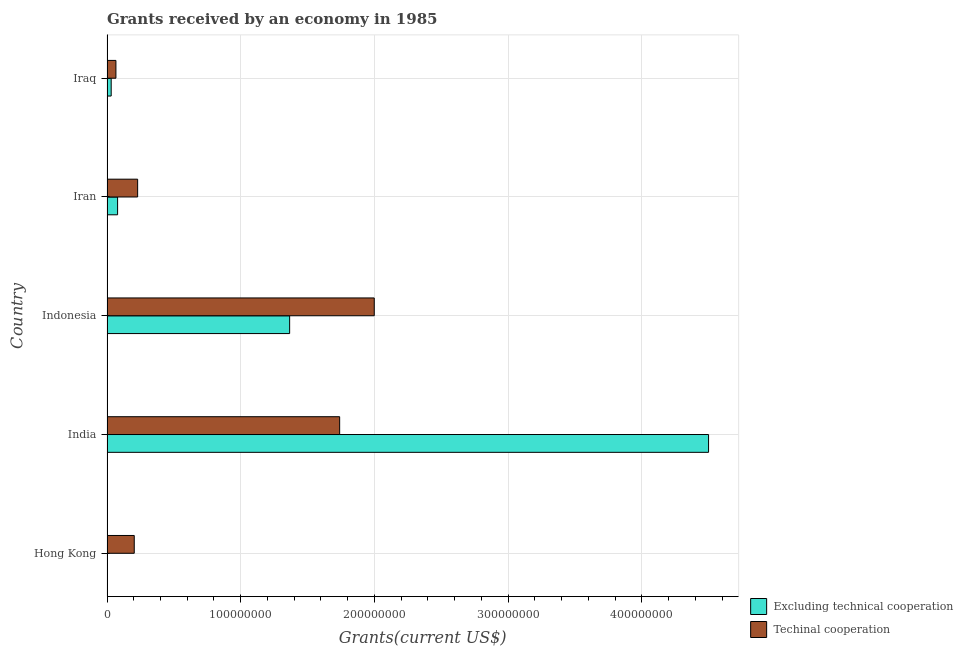Are the number of bars per tick equal to the number of legend labels?
Give a very brief answer. Yes. Are the number of bars on each tick of the Y-axis equal?
Offer a terse response. Yes. How many bars are there on the 2nd tick from the bottom?
Make the answer very short. 2. What is the label of the 2nd group of bars from the top?
Your answer should be compact. Iran. In how many cases, is the number of bars for a given country not equal to the number of legend labels?
Provide a succinct answer. 0. What is the amount of grants received(including technical cooperation) in India?
Keep it short and to the point. 1.74e+08. Across all countries, what is the maximum amount of grants received(excluding technical cooperation)?
Keep it short and to the point. 4.50e+08. Across all countries, what is the minimum amount of grants received(including technical cooperation)?
Ensure brevity in your answer.  6.67e+06. In which country was the amount of grants received(excluding technical cooperation) minimum?
Keep it short and to the point. Hong Kong. What is the total amount of grants received(excluding technical cooperation) in the graph?
Make the answer very short. 5.97e+08. What is the difference between the amount of grants received(excluding technical cooperation) in India and that in Indonesia?
Make the answer very short. 3.13e+08. What is the difference between the amount of grants received(excluding technical cooperation) in Iran and the amount of grants received(including technical cooperation) in India?
Your answer should be compact. -1.66e+08. What is the average amount of grants received(including technical cooperation) per country?
Provide a short and direct response. 8.48e+07. What is the difference between the amount of grants received(including technical cooperation) and amount of grants received(excluding technical cooperation) in Hong Kong?
Offer a terse response. 2.04e+07. In how many countries, is the amount of grants received(including technical cooperation) greater than 420000000 US$?
Give a very brief answer. 0. What is the ratio of the amount of grants received(including technical cooperation) in Hong Kong to that in Iraq?
Ensure brevity in your answer.  3.05. Is the difference between the amount of grants received(including technical cooperation) in Hong Kong and Iraq greater than the difference between the amount of grants received(excluding technical cooperation) in Hong Kong and Iraq?
Provide a short and direct response. Yes. What is the difference between the highest and the second highest amount of grants received(including technical cooperation)?
Your answer should be compact. 2.59e+07. What is the difference between the highest and the lowest amount of grants received(including technical cooperation)?
Your response must be concise. 1.93e+08. In how many countries, is the amount of grants received(excluding technical cooperation) greater than the average amount of grants received(excluding technical cooperation) taken over all countries?
Your answer should be very brief. 2. Is the sum of the amount of grants received(excluding technical cooperation) in Iran and Iraq greater than the maximum amount of grants received(including technical cooperation) across all countries?
Offer a very short reply. No. What does the 1st bar from the top in Iraq represents?
Make the answer very short. Techinal cooperation. What does the 2nd bar from the bottom in India represents?
Make the answer very short. Techinal cooperation. How many bars are there?
Offer a terse response. 10. Are all the bars in the graph horizontal?
Ensure brevity in your answer.  Yes. How are the legend labels stacked?
Your answer should be compact. Vertical. What is the title of the graph?
Offer a very short reply. Grants received by an economy in 1985. Does "Total Population" appear as one of the legend labels in the graph?
Offer a terse response. No. What is the label or title of the X-axis?
Offer a terse response. Grants(current US$). What is the label or title of the Y-axis?
Provide a succinct answer. Country. What is the Grants(current US$) of Excluding technical cooperation in Hong Kong?
Provide a short and direct response. 2.00e+04. What is the Grants(current US$) of Techinal cooperation in Hong Kong?
Your response must be concise. 2.04e+07. What is the Grants(current US$) of Excluding technical cooperation in India?
Offer a very short reply. 4.50e+08. What is the Grants(current US$) of Techinal cooperation in India?
Make the answer very short. 1.74e+08. What is the Grants(current US$) in Excluding technical cooperation in Indonesia?
Make the answer very short. 1.37e+08. What is the Grants(current US$) of Techinal cooperation in Indonesia?
Make the answer very short. 2.00e+08. What is the Grants(current US$) of Excluding technical cooperation in Iran?
Provide a succinct answer. 7.92e+06. What is the Grants(current US$) of Techinal cooperation in Iran?
Provide a short and direct response. 2.29e+07. What is the Grants(current US$) in Excluding technical cooperation in Iraq?
Your answer should be very brief. 3.13e+06. What is the Grants(current US$) of Techinal cooperation in Iraq?
Provide a succinct answer. 6.67e+06. Across all countries, what is the maximum Grants(current US$) in Excluding technical cooperation?
Give a very brief answer. 4.50e+08. Across all countries, what is the maximum Grants(current US$) of Techinal cooperation?
Keep it short and to the point. 2.00e+08. Across all countries, what is the minimum Grants(current US$) of Excluding technical cooperation?
Keep it short and to the point. 2.00e+04. Across all countries, what is the minimum Grants(current US$) in Techinal cooperation?
Offer a terse response. 6.67e+06. What is the total Grants(current US$) of Excluding technical cooperation in the graph?
Provide a succinct answer. 5.97e+08. What is the total Grants(current US$) in Techinal cooperation in the graph?
Offer a very short reply. 4.24e+08. What is the difference between the Grants(current US$) in Excluding technical cooperation in Hong Kong and that in India?
Give a very brief answer. -4.50e+08. What is the difference between the Grants(current US$) in Techinal cooperation in Hong Kong and that in India?
Make the answer very short. -1.54e+08. What is the difference between the Grants(current US$) in Excluding technical cooperation in Hong Kong and that in Indonesia?
Provide a short and direct response. -1.37e+08. What is the difference between the Grants(current US$) in Techinal cooperation in Hong Kong and that in Indonesia?
Ensure brevity in your answer.  -1.79e+08. What is the difference between the Grants(current US$) in Excluding technical cooperation in Hong Kong and that in Iran?
Make the answer very short. -7.90e+06. What is the difference between the Grants(current US$) of Techinal cooperation in Hong Kong and that in Iran?
Offer a terse response. -2.54e+06. What is the difference between the Grants(current US$) of Excluding technical cooperation in Hong Kong and that in Iraq?
Make the answer very short. -3.11e+06. What is the difference between the Grants(current US$) of Techinal cooperation in Hong Kong and that in Iraq?
Your answer should be very brief. 1.37e+07. What is the difference between the Grants(current US$) of Excluding technical cooperation in India and that in Indonesia?
Give a very brief answer. 3.13e+08. What is the difference between the Grants(current US$) in Techinal cooperation in India and that in Indonesia?
Make the answer very short. -2.59e+07. What is the difference between the Grants(current US$) in Excluding technical cooperation in India and that in Iran?
Ensure brevity in your answer.  4.42e+08. What is the difference between the Grants(current US$) in Techinal cooperation in India and that in Iran?
Offer a very short reply. 1.51e+08. What is the difference between the Grants(current US$) of Excluding technical cooperation in India and that in Iraq?
Make the answer very short. 4.47e+08. What is the difference between the Grants(current US$) in Techinal cooperation in India and that in Iraq?
Make the answer very short. 1.67e+08. What is the difference between the Grants(current US$) in Excluding technical cooperation in Indonesia and that in Iran?
Your response must be concise. 1.29e+08. What is the difference between the Grants(current US$) in Techinal cooperation in Indonesia and that in Iran?
Ensure brevity in your answer.  1.77e+08. What is the difference between the Grants(current US$) in Excluding technical cooperation in Indonesia and that in Iraq?
Give a very brief answer. 1.33e+08. What is the difference between the Grants(current US$) of Techinal cooperation in Indonesia and that in Iraq?
Your answer should be compact. 1.93e+08. What is the difference between the Grants(current US$) in Excluding technical cooperation in Iran and that in Iraq?
Make the answer very short. 4.79e+06. What is the difference between the Grants(current US$) of Techinal cooperation in Iran and that in Iraq?
Keep it short and to the point. 1.62e+07. What is the difference between the Grants(current US$) in Excluding technical cooperation in Hong Kong and the Grants(current US$) in Techinal cooperation in India?
Make the answer very short. -1.74e+08. What is the difference between the Grants(current US$) of Excluding technical cooperation in Hong Kong and the Grants(current US$) of Techinal cooperation in Indonesia?
Your answer should be compact. -2.00e+08. What is the difference between the Grants(current US$) of Excluding technical cooperation in Hong Kong and the Grants(current US$) of Techinal cooperation in Iran?
Ensure brevity in your answer.  -2.29e+07. What is the difference between the Grants(current US$) in Excluding technical cooperation in Hong Kong and the Grants(current US$) in Techinal cooperation in Iraq?
Your response must be concise. -6.65e+06. What is the difference between the Grants(current US$) in Excluding technical cooperation in India and the Grants(current US$) in Techinal cooperation in Indonesia?
Offer a terse response. 2.50e+08. What is the difference between the Grants(current US$) of Excluding technical cooperation in India and the Grants(current US$) of Techinal cooperation in Iran?
Provide a short and direct response. 4.27e+08. What is the difference between the Grants(current US$) in Excluding technical cooperation in India and the Grants(current US$) in Techinal cooperation in Iraq?
Provide a succinct answer. 4.43e+08. What is the difference between the Grants(current US$) in Excluding technical cooperation in Indonesia and the Grants(current US$) in Techinal cooperation in Iran?
Your answer should be compact. 1.14e+08. What is the difference between the Grants(current US$) in Excluding technical cooperation in Indonesia and the Grants(current US$) in Techinal cooperation in Iraq?
Make the answer very short. 1.30e+08. What is the difference between the Grants(current US$) of Excluding technical cooperation in Iran and the Grants(current US$) of Techinal cooperation in Iraq?
Your answer should be compact. 1.25e+06. What is the average Grants(current US$) of Excluding technical cooperation per country?
Your answer should be compact. 1.19e+08. What is the average Grants(current US$) in Techinal cooperation per country?
Your answer should be compact. 8.48e+07. What is the difference between the Grants(current US$) in Excluding technical cooperation and Grants(current US$) in Techinal cooperation in Hong Kong?
Your response must be concise. -2.04e+07. What is the difference between the Grants(current US$) in Excluding technical cooperation and Grants(current US$) in Techinal cooperation in India?
Ensure brevity in your answer.  2.76e+08. What is the difference between the Grants(current US$) of Excluding technical cooperation and Grants(current US$) of Techinal cooperation in Indonesia?
Ensure brevity in your answer.  -6.33e+07. What is the difference between the Grants(current US$) in Excluding technical cooperation and Grants(current US$) in Techinal cooperation in Iran?
Your response must be concise. -1.50e+07. What is the difference between the Grants(current US$) of Excluding technical cooperation and Grants(current US$) of Techinal cooperation in Iraq?
Keep it short and to the point. -3.54e+06. What is the ratio of the Grants(current US$) of Excluding technical cooperation in Hong Kong to that in India?
Your answer should be very brief. 0. What is the ratio of the Grants(current US$) in Techinal cooperation in Hong Kong to that in India?
Your answer should be compact. 0.12. What is the ratio of the Grants(current US$) in Excluding technical cooperation in Hong Kong to that in Indonesia?
Your response must be concise. 0. What is the ratio of the Grants(current US$) of Techinal cooperation in Hong Kong to that in Indonesia?
Give a very brief answer. 0.1. What is the ratio of the Grants(current US$) of Excluding technical cooperation in Hong Kong to that in Iran?
Ensure brevity in your answer.  0. What is the ratio of the Grants(current US$) in Techinal cooperation in Hong Kong to that in Iran?
Make the answer very short. 0.89. What is the ratio of the Grants(current US$) of Excluding technical cooperation in Hong Kong to that in Iraq?
Give a very brief answer. 0.01. What is the ratio of the Grants(current US$) of Techinal cooperation in Hong Kong to that in Iraq?
Ensure brevity in your answer.  3.05. What is the ratio of the Grants(current US$) in Excluding technical cooperation in India to that in Indonesia?
Your response must be concise. 3.29. What is the ratio of the Grants(current US$) of Techinal cooperation in India to that in Indonesia?
Your response must be concise. 0.87. What is the ratio of the Grants(current US$) of Excluding technical cooperation in India to that in Iran?
Make the answer very short. 56.8. What is the ratio of the Grants(current US$) of Techinal cooperation in India to that in Iran?
Offer a terse response. 7.59. What is the ratio of the Grants(current US$) in Excluding technical cooperation in India to that in Iraq?
Provide a succinct answer. 143.72. What is the ratio of the Grants(current US$) of Techinal cooperation in India to that in Iraq?
Your answer should be very brief. 26.08. What is the ratio of the Grants(current US$) in Excluding technical cooperation in Indonesia to that in Iran?
Make the answer very short. 17.24. What is the ratio of the Grants(current US$) of Techinal cooperation in Indonesia to that in Iran?
Offer a very short reply. 8.72. What is the ratio of the Grants(current US$) of Excluding technical cooperation in Indonesia to that in Iraq?
Offer a terse response. 43.64. What is the ratio of the Grants(current US$) of Techinal cooperation in Indonesia to that in Iraq?
Ensure brevity in your answer.  29.96. What is the ratio of the Grants(current US$) of Excluding technical cooperation in Iran to that in Iraq?
Keep it short and to the point. 2.53. What is the ratio of the Grants(current US$) in Techinal cooperation in Iran to that in Iraq?
Your response must be concise. 3.43. What is the difference between the highest and the second highest Grants(current US$) in Excluding technical cooperation?
Your answer should be compact. 3.13e+08. What is the difference between the highest and the second highest Grants(current US$) in Techinal cooperation?
Offer a terse response. 2.59e+07. What is the difference between the highest and the lowest Grants(current US$) in Excluding technical cooperation?
Ensure brevity in your answer.  4.50e+08. What is the difference between the highest and the lowest Grants(current US$) in Techinal cooperation?
Your answer should be compact. 1.93e+08. 